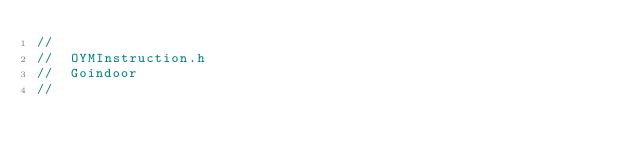<code> <loc_0><loc_0><loc_500><loc_500><_C_>//
//  OYMInstruction.h
//  Goindoor
//</code> 